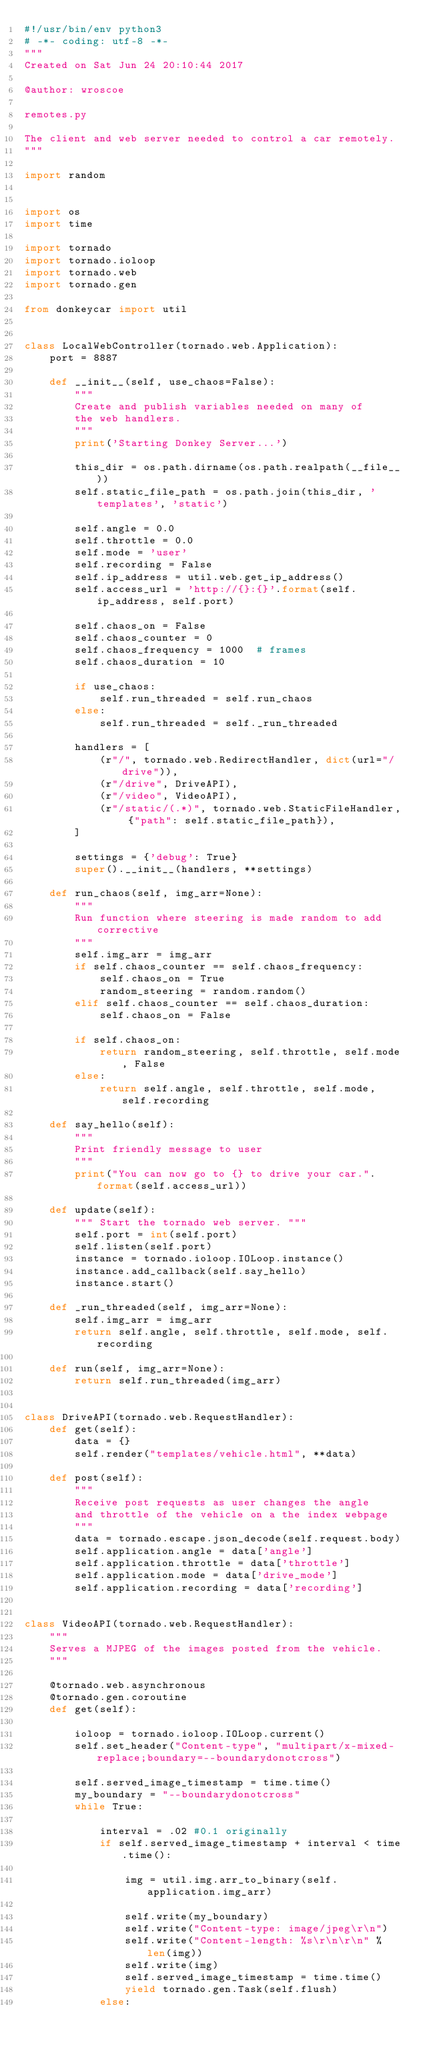<code> <loc_0><loc_0><loc_500><loc_500><_Python_>#!/usr/bin/env python3
# -*- coding: utf-8 -*-
"""
Created on Sat Jun 24 20:10:44 2017

@author: wroscoe

remotes.py

The client and web server needed to control a car remotely.
"""

import random


import os
import time

import tornado
import tornado.ioloop
import tornado.web
import tornado.gen

from donkeycar import util


class LocalWebController(tornado.web.Application):
    port = 8887

    def __init__(self, use_chaos=False):
        """
        Create and publish variables needed on many of
        the web handlers.
        """
        print('Starting Donkey Server...')

        this_dir = os.path.dirname(os.path.realpath(__file__))
        self.static_file_path = os.path.join(this_dir, 'templates', 'static')

        self.angle = 0.0
        self.throttle = 0.0
        self.mode = 'user'
        self.recording = False
        self.ip_address = util.web.get_ip_address()
        self.access_url = 'http://{}:{}'.format(self.ip_address, self.port)

        self.chaos_on = False
        self.chaos_counter = 0
        self.chaos_frequency = 1000  # frames
        self.chaos_duration = 10

        if use_chaos:
            self.run_threaded = self.run_chaos
        else:
            self.run_threaded = self._run_threaded

        handlers = [
            (r"/", tornado.web.RedirectHandler, dict(url="/drive")),
            (r"/drive", DriveAPI),
            (r"/video", VideoAPI),
            (r"/static/(.*)", tornado.web.StaticFileHandler, {"path": self.static_file_path}),
        ]

        settings = {'debug': True}
        super().__init__(handlers, **settings)

    def run_chaos(self, img_arr=None):
        """
        Run function where steering is made random to add corrective
        """
        self.img_arr = img_arr
        if self.chaos_counter == self.chaos_frequency:
            self.chaos_on = True
            random_steering = random.random()
        elif self.chaos_counter == self.chaos_duration:
            self.chaos_on = False

        if self.chaos_on:
            return random_steering, self.throttle, self.mode, False
        else:
            return self.angle, self.throttle, self.mode, self.recording

    def say_hello(self):
        """
        Print friendly message to user
        """
        print("You can now go to {} to drive your car.".format(self.access_url))

    def update(self):
        """ Start the tornado web server. """
        self.port = int(self.port)
        self.listen(self.port)
        instance = tornado.ioloop.IOLoop.instance()
        instance.add_callback(self.say_hello)
        instance.start()

    def _run_threaded(self, img_arr=None):
        self.img_arr = img_arr
        return self.angle, self.throttle, self.mode, self.recording

    def run(self, img_arr=None):
        return self.run_threaded(img_arr)


class DriveAPI(tornado.web.RequestHandler):
    def get(self):
        data = {}
        self.render("templates/vehicle.html", **data)

    def post(self):
        """
        Receive post requests as user changes the angle
        and throttle of the vehicle on a the index webpage
        """
        data = tornado.escape.json_decode(self.request.body)
        self.application.angle = data['angle']
        self.application.throttle = data['throttle']
        self.application.mode = data['drive_mode']
        self.application.recording = data['recording']


class VideoAPI(tornado.web.RequestHandler):
    """
    Serves a MJPEG of the images posted from the vehicle.
    """

    @tornado.web.asynchronous
    @tornado.gen.coroutine
    def get(self):

        ioloop = tornado.ioloop.IOLoop.current()
        self.set_header("Content-type", "multipart/x-mixed-replace;boundary=--boundarydonotcross")

        self.served_image_timestamp = time.time()
        my_boundary = "--boundarydonotcross"
        while True:

            interval = .02 #0.1 originally
            if self.served_image_timestamp + interval < time.time():

                img = util.img.arr_to_binary(self.application.img_arr)

                self.write(my_boundary)
                self.write("Content-type: image/jpeg\r\n")
                self.write("Content-length: %s\r\n\r\n" % len(img))
                self.write(img)
                self.served_image_timestamp = time.time()
                yield tornado.gen.Task(self.flush)
            else:</code> 